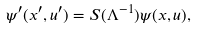Convert formula to latex. <formula><loc_0><loc_0><loc_500><loc_500>\psi ^ { \prime } ( x ^ { \prime } , u ^ { \prime } ) = S ( \Lambda ^ { - 1 } ) \psi ( x , u ) ,</formula> 